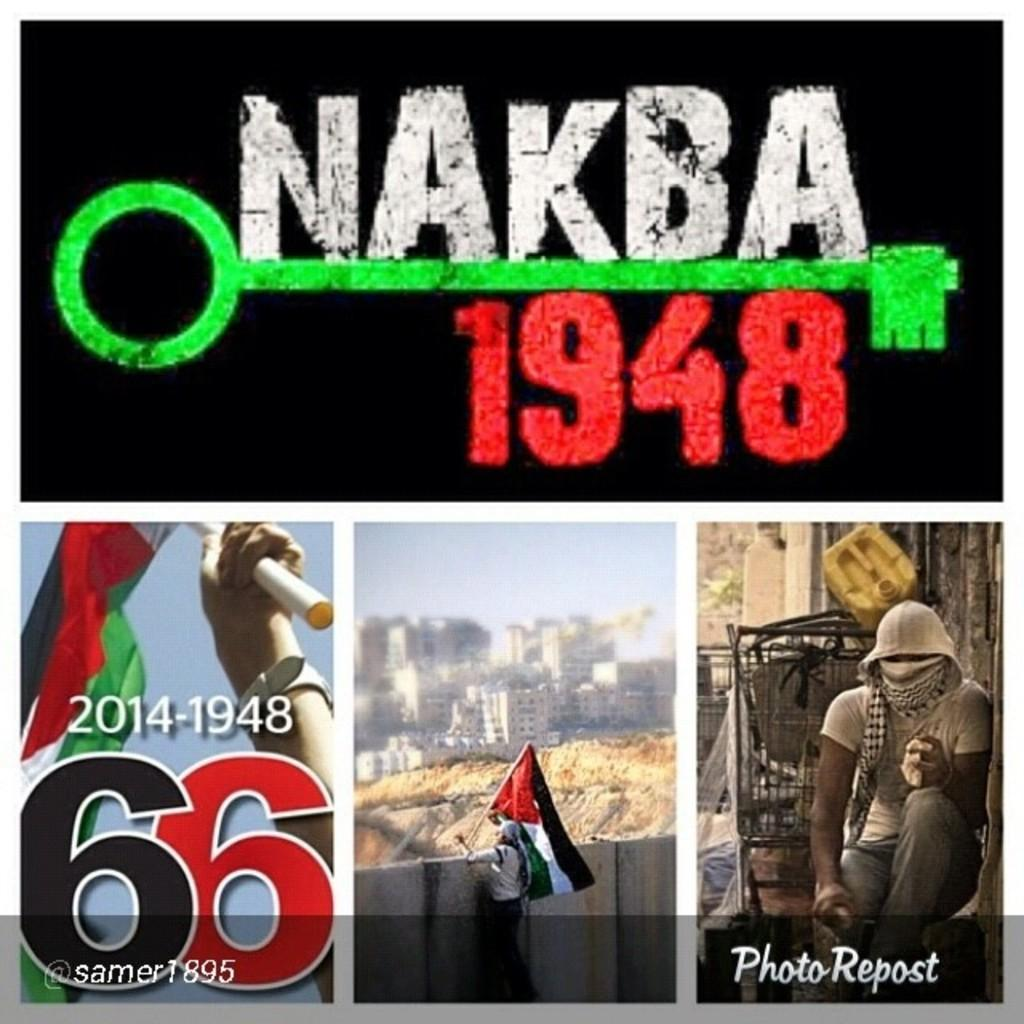What type of content is featured in the image? The image contains a collage of advertisements. Can you describe the format of the content in the image? The content is presented in a collage format, with multiple advertisements displayed together. What type of bottle is being advertised in the image? There is no specific bottle being advertised in the image, as it contains a collage of various advertisements. 